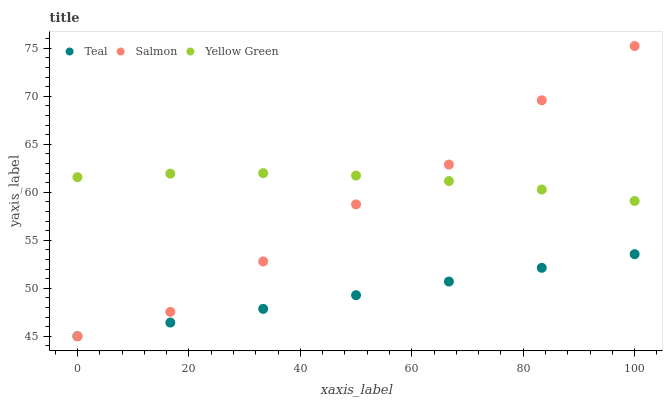Does Teal have the minimum area under the curve?
Answer yes or no. Yes. Does Yellow Green have the maximum area under the curve?
Answer yes or no. Yes. Does Yellow Green have the minimum area under the curve?
Answer yes or no. No. Does Teal have the maximum area under the curve?
Answer yes or no. No. Is Teal the smoothest?
Answer yes or no. Yes. Is Salmon the roughest?
Answer yes or no. Yes. Is Yellow Green the smoothest?
Answer yes or no. No. Is Yellow Green the roughest?
Answer yes or no. No. Does Salmon have the lowest value?
Answer yes or no. Yes. Does Yellow Green have the lowest value?
Answer yes or no. No. Does Salmon have the highest value?
Answer yes or no. Yes. Does Yellow Green have the highest value?
Answer yes or no. No. Is Teal less than Yellow Green?
Answer yes or no. Yes. Is Yellow Green greater than Teal?
Answer yes or no. Yes. Does Salmon intersect Yellow Green?
Answer yes or no. Yes. Is Salmon less than Yellow Green?
Answer yes or no. No. Is Salmon greater than Yellow Green?
Answer yes or no. No. Does Teal intersect Yellow Green?
Answer yes or no. No. 